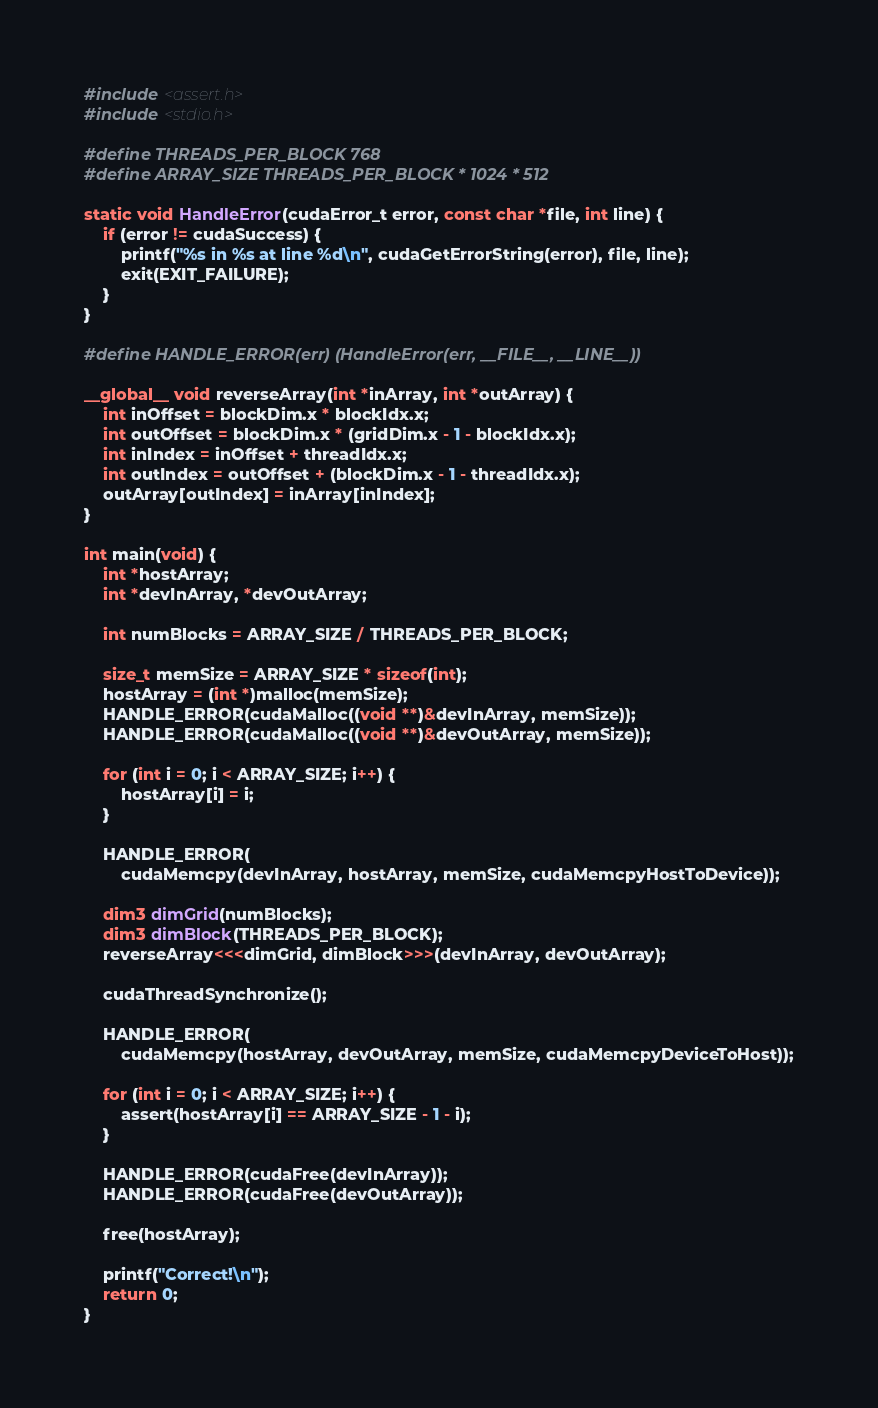Convert code to text. <code><loc_0><loc_0><loc_500><loc_500><_Cuda_>#include <assert.h>
#include <stdio.h>

#define THREADS_PER_BLOCK 768
#define ARRAY_SIZE THREADS_PER_BLOCK * 1024 * 512

static void HandleError(cudaError_t error, const char *file, int line) {
    if (error != cudaSuccess) {
        printf("%s in %s at line %d\n", cudaGetErrorString(error), file, line);
        exit(EXIT_FAILURE);
    }
}

#define HANDLE_ERROR(err) (HandleError(err, __FILE__, __LINE__))

__global__ void reverseArray(int *inArray, int *outArray) {
    int inOffset = blockDim.x * blockIdx.x;
    int outOffset = blockDim.x * (gridDim.x - 1 - blockIdx.x);
    int inIndex = inOffset + threadIdx.x;
    int outIndex = outOffset + (blockDim.x - 1 - threadIdx.x);
    outArray[outIndex] = inArray[inIndex];
}

int main(void) {
    int *hostArray;
    int *devInArray, *devOutArray;

    int numBlocks = ARRAY_SIZE / THREADS_PER_BLOCK;

    size_t memSize = ARRAY_SIZE * sizeof(int);
    hostArray = (int *)malloc(memSize);
    HANDLE_ERROR(cudaMalloc((void **)&devInArray, memSize));
    HANDLE_ERROR(cudaMalloc((void **)&devOutArray, memSize));

    for (int i = 0; i < ARRAY_SIZE; i++) {
        hostArray[i] = i;
    }

    HANDLE_ERROR(
        cudaMemcpy(devInArray, hostArray, memSize, cudaMemcpyHostToDevice));

    dim3 dimGrid(numBlocks);
    dim3 dimBlock(THREADS_PER_BLOCK);
    reverseArray<<<dimGrid, dimBlock>>>(devInArray, devOutArray);

    cudaThreadSynchronize();

    HANDLE_ERROR(
        cudaMemcpy(hostArray, devOutArray, memSize, cudaMemcpyDeviceToHost));

    for (int i = 0; i < ARRAY_SIZE; i++) {
        assert(hostArray[i] == ARRAY_SIZE - 1 - i);
    }

    HANDLE_ERROR(cudaFree(devInArray));
    HANDLE_ERROR(cudaFree(devOutArray));

    free(hostArray);

    printf("Correct!\n");
    return 0;
}
</code> 